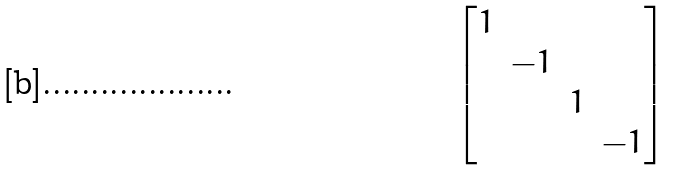<formula> <loc_0><loc_0><loc_500><loc_500>\begin{bmatrix} 1 \\ & - 1 \\ & & 1 \\ & & & - 1 \end{bmatrix}</formula> 